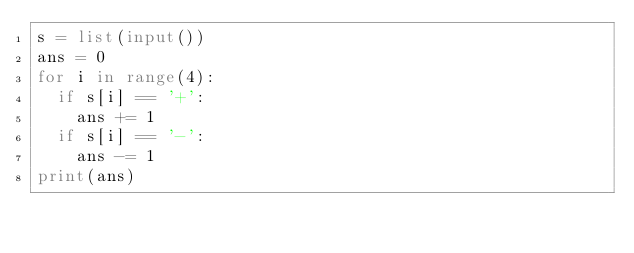<code> <loc_0><loc_0><loc_500><loc_500><_Python_>s = list(input())
ans = 0
for i in range(4):
	if s[i] == '+':
		ans += 1
	if s[i] == '-':
		ans -= 1
print(ans)</code> 